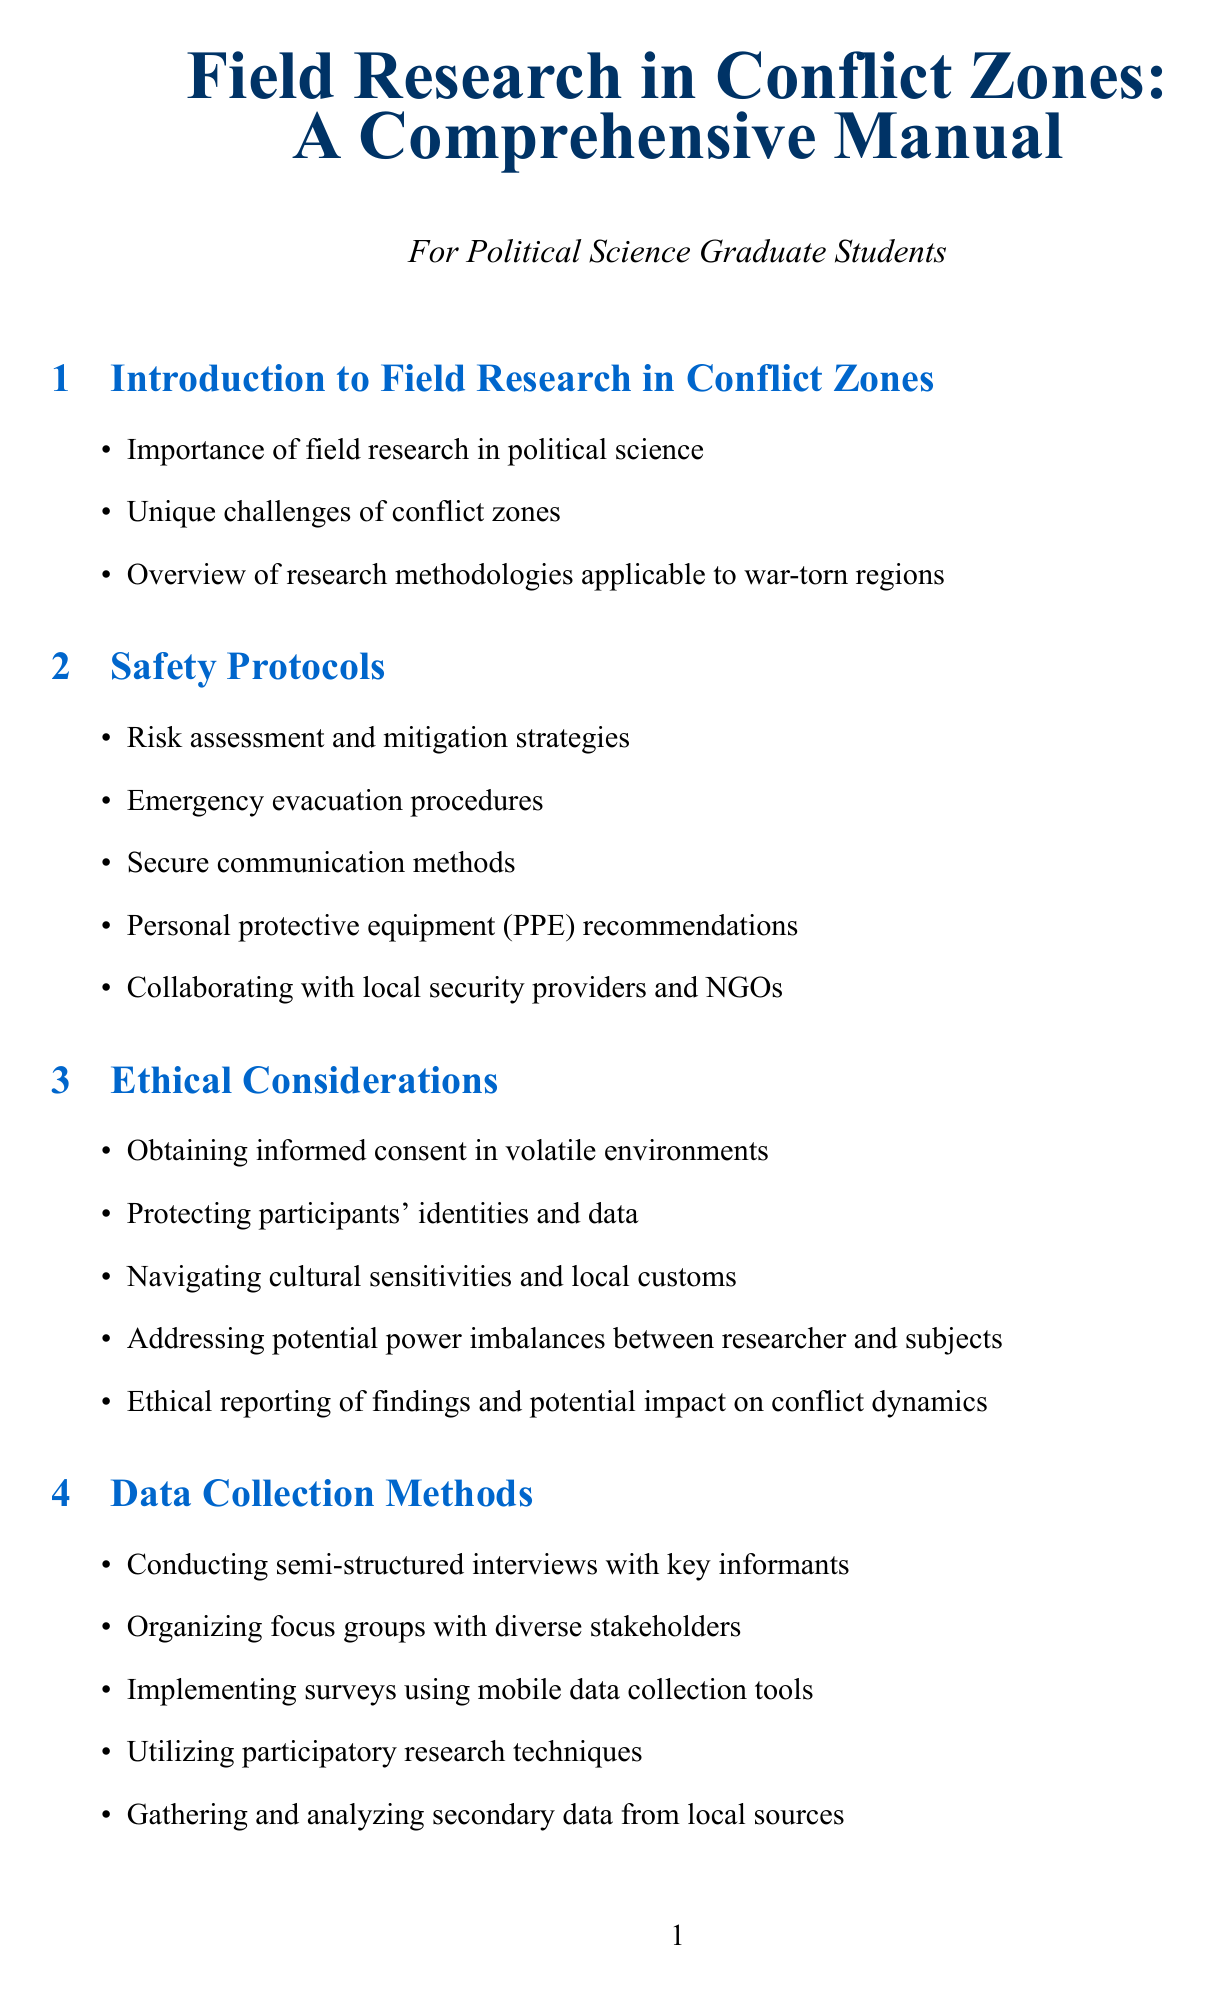What is the first section of the manual? The first section details the significance and challenges associated with conducting research in conflict zones.
Answer: Introduction to Field Research in Conflict Zones How many subsections are under Safety Protocols? The manual outlines various safety measures for conducting field research, listing specific protocols in the Safety section.
Answer: Five What is a recommended data collection method mentioned in the manual? The manual provides several effective methods for gathering information in conflict zones.
Answer: Conducting semi-structured interviews with key informants Name one organization mentioned in the case studies section. The document includes examples of field research efforts by well-known organizations working in conflict zones.
Answer: International Crisis Group What is emphasized in the ethical considerations section? The section addresses critical aspects of maintaining ethical standards while conducting sensitive research in dangerous environments.
Answer: Protecting participants' identities and data What is one practical consideration highlighted in the manual? The manual mentions various factors that researchers need to manage effectively to ensure successful outcomes during their field research.
Answer: Budgeting for unexpected expenses and security measures What is one aspect of building trust with participants? The manual outlines crucial strategies for establishing a good rapport with individuals in conflict-affected regions.
Answer: Strategies for gaining access to conflict-affected communities How can researchers ensure data security according to the manual? The document outlines techniques and methods to securely handle collected data during research in hazardous environments.
Answer: Secure data storage and encryption methods 